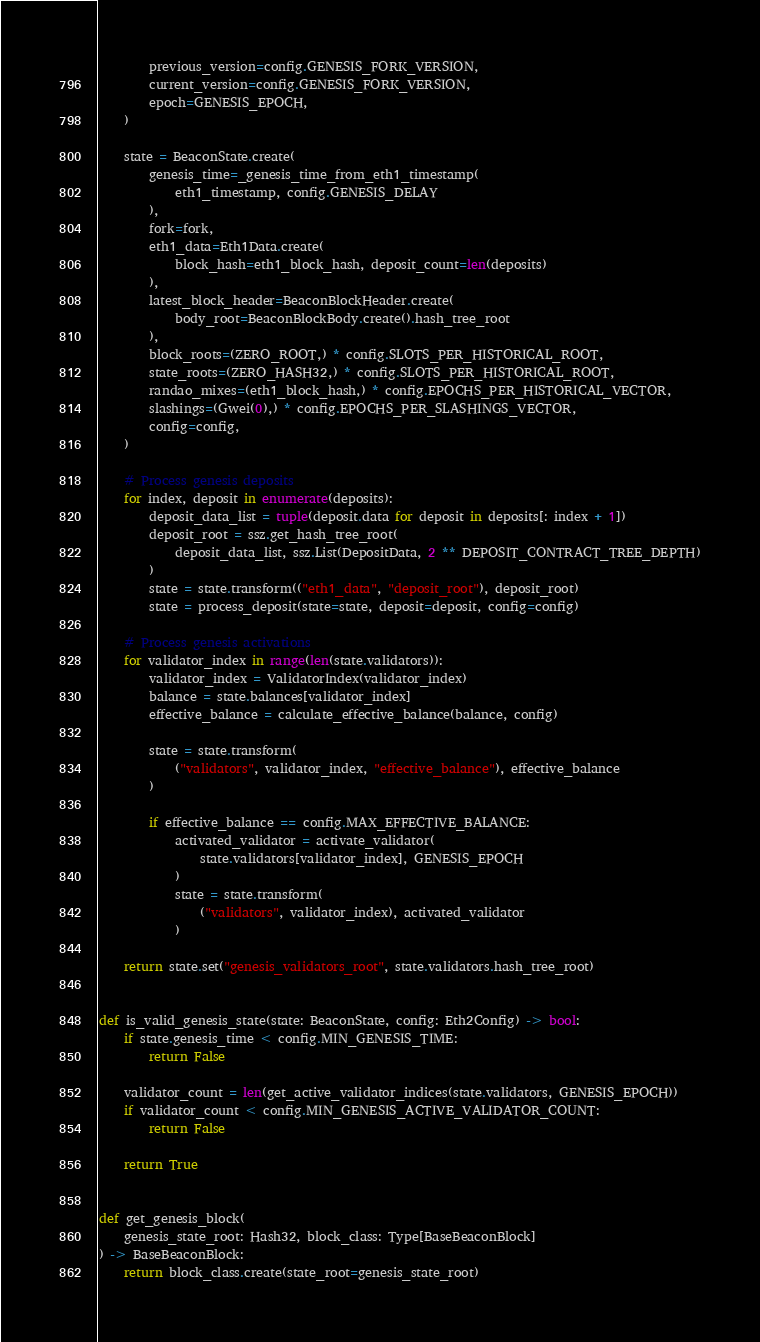<code> <loc_0><loc_0><loc_500><loc_500><_Python_>        previous_version=config.GENESIS_FORK_VERSION,
        current_version=config.GENESIS_FORK_VERSION,
        epoch=GENESIS_EPOCH,
    )

    state = BeaconState.create(
        genesis_time=_genesis_time_from_eth1_timestamp(
            eth1_timestamp, config.GENESIS_DELAY
        ),
        fork=fork,
        eth1_data=Eth1Data.create(
            block_hash=eth1_block_hash, deposit_count=len(deposits)
        ),
        latest_block_header=BeaconBlockHeader.create(
            body_root=BeaconBlockBody.create().hash_tree_root
        ),
        block_roots=(ZERO_ROOT,) * config.SLOTS_PER_HISTORICAL_ROOT,
        state_roots=(ZERO_HASH32,) * config.SLOTS_PER_HISTORICAL_ROOT,
        randao_mixes=(eth1_block_hash,) * config.EPOCHS_PER_HISTORICAL_VECTOR,
        slashings=(Gwei(0),) * config.EPOCHS_PER_SLASHINGS_VECTOR,
        config=config,
    )

    # Process genesis deposits
    for index, deposit in enumerate(deposits):
        deposit_data_list = tuple(deposit.data for deposit in deposits[: index + 1])
        deposit_root = ssz.get_hash_tree_root(
            deposit_data_list, ssz.List(DepositData, 2 ** DEPOSIT_CONTRACT_TREE_DEPTH)
        )
        state = state.transform(("eth1_data", "deposit_root"), deposit_root)
        state = process_deposit(state=state, deposit=deposit, config=config)

    # Process genesis activations
    for validator_index in range(len(state.validators)):
        validator_index = ValidatorIndex(validator_index)
        balance = state.balances[validator_index]
        effective_balance = calculate_effective_balance(balance, config)

        state = state.transform(
            ("validators", validator_index, "effective_balance"), effective_balance
        )

        if effective_balance == config.MAX_EFFECTIVE_BALANCE:
            activated_validator = activate_validator(
                state.validators[validator_index], GENESIS_EPOCH
            )
            state = state.transform(
                ("validators", validator_index), activated_validator
            )

    return state.set("genesis_validators_root", state.validators.hash_tree_root)


def is_valid_genesis_state(state: BeaconState, config: Eth2Config) -> bool:
    if state.genesis_time < config.MIN_GENESIS_TIME:
        return False

    validator_count = len(get_active_validator_indices(state.validators, GENESIS_EPOCH))
    if validator_count < config.MIN_GENESIS_ACTIVE_VALIDATOR_COUNT:
        return False

    return True


def get_genesis_block(
    genesis_state_root: Hash32, block_class: Type[BaseBeaconBlock]
) -> BaseBeaconBlock:
    return block_class.create(state_root=genesis_state_root)
</code> 